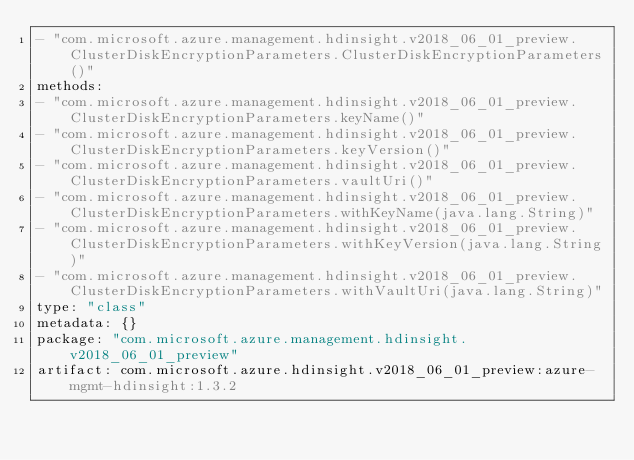Convert code to text. <code><loc_0><loc_0><loc_500><loc_500><_YAML_>- "com.microsoft.azure.management.hdinsight.v2018_06_01_preview.ClusterDiskEncryptionParameters.ClusterDiskEncryptionParameters()"
methods:
- "com.microsoft.azure.management.hdinsight.v2018_06_01_preview.ClusterDiskEncryptionParameters.keyName()"
- "com.microsoft.azure.management.hdinsight.v2018_06_01_preview.ClusterDiskEncryptionParameters.keyVersion()"
- "com.microsoft.azure.management.hdinsight.v2018_06_01_preview.ClusterDiskEncryptionParameters.vaultUri()"
- "com.microsoft.azure.management.hdinsight.v2018_06_01_preview.ClusterDiskEncryptionParameters.withKeyName(java.lang.String)"
- "com.microsoft.azure.management.hdinsight.v2018_06_01_preview.ClusterDiskEncryptionParameters.withKeyVersion(java.lang.String)"
- "com.microsoft.azure.management.hdinsight.v2018_06_01_preview.ClusterDiskEncryptionParameters.withVaultUri(java.lang.String)"
type: "class"
metadata: {}
package: "com.microsoft.azure.management.hdinsight.v2018_06_01_preview"
artifact: com.microsoft.azure.hdinsight.v2018_06_01_preview:azure-mgmt-hdinsight:1.3.2
</code> 